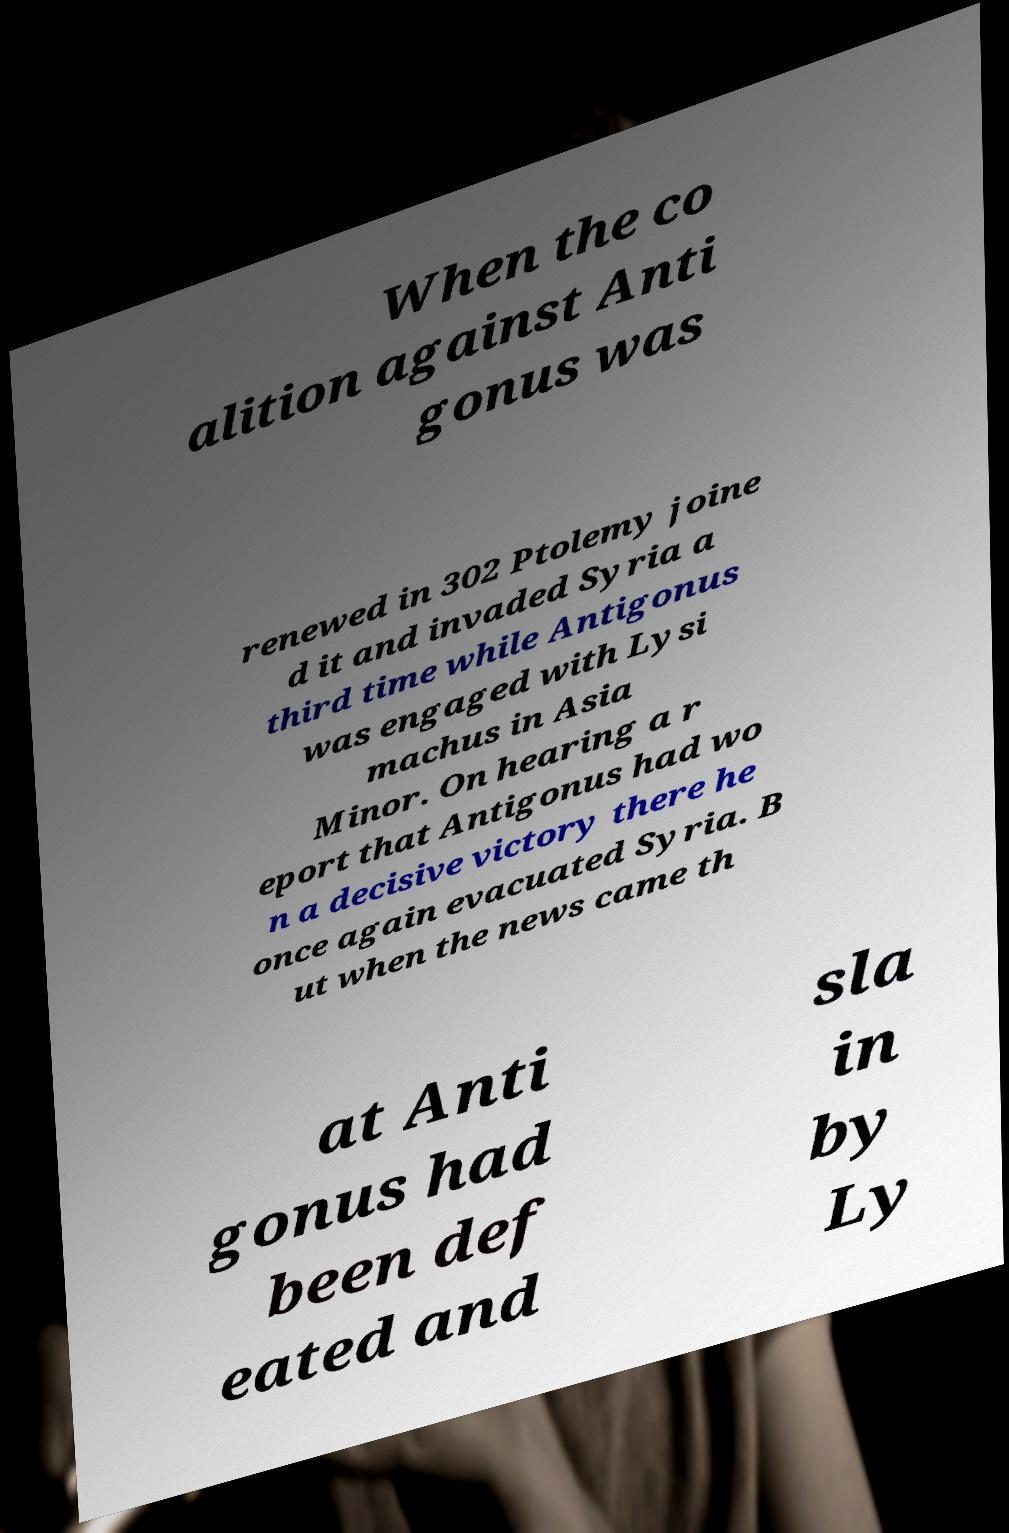Please identify and transcribe the text found in this image. When the co alition against Anti gonus was renewed in 302 Ptolemy joine d it and invaded Syria a third time while Antigonus was engaged with Lysi machus in Asia Minor. On hearing a r eport that Antigonus had wo n a decisive victory there he once again evacuated Syria. B ut when the news came th at Anti gonus had been def eated and sla in by Ly 